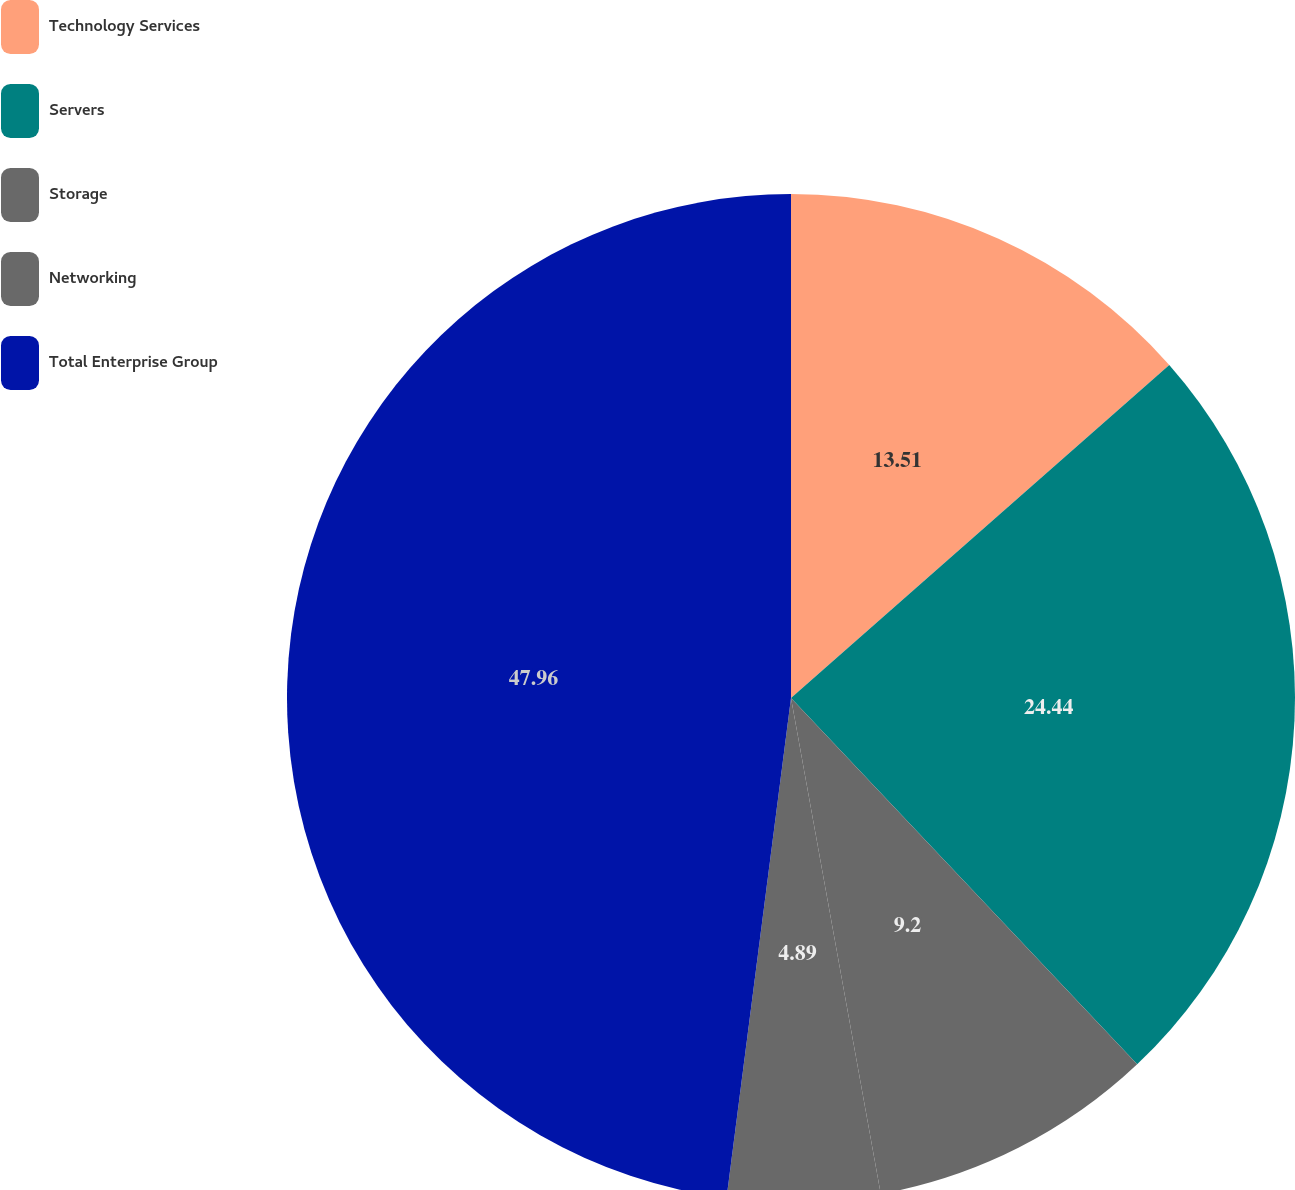<chart> <loc_0><loc_0><loc_500><loc_500><pie_chart><fcel>Technology Services<fcel>Servers<fcel>Storage<fcel>Networking<fcel>Total Enterprise Group<nl><fcel>13.51%<fcel>24.44%<fcel>9.2%<fcel>4.89%<fcel>47.96%<nl></chart> 